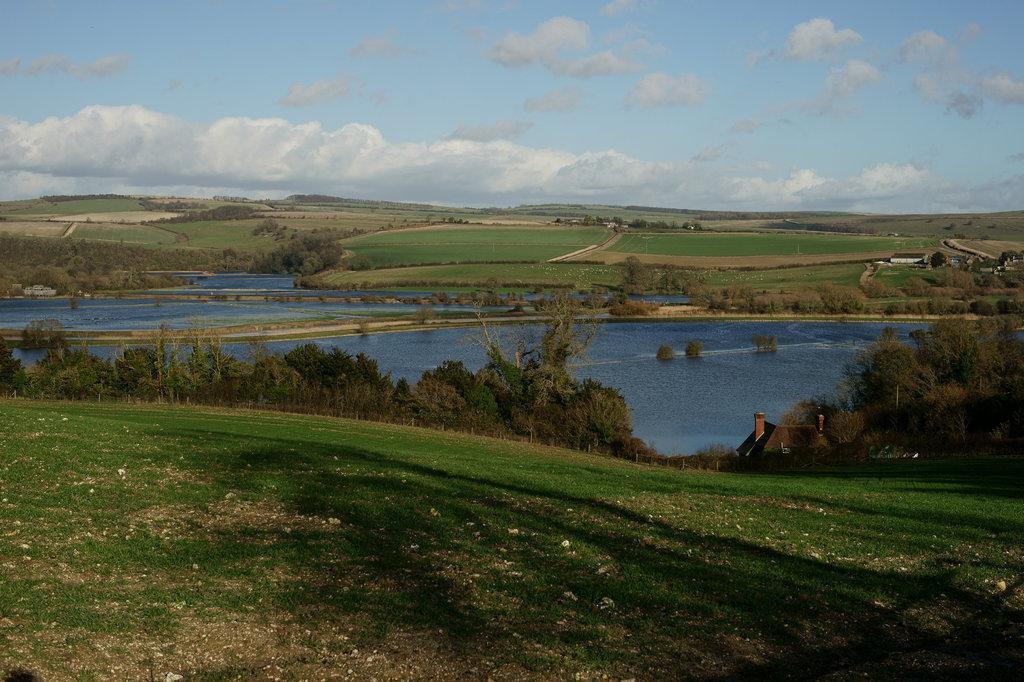Could you give a brief overview of what you see in this image? At the bottom of the picture, we see the grass. In the middle, we see the trees and a hut. Beside that, we see water and this water might be in the lake. There are trees, grass and a building in the background. At the top, we see the sky and the clouds. 